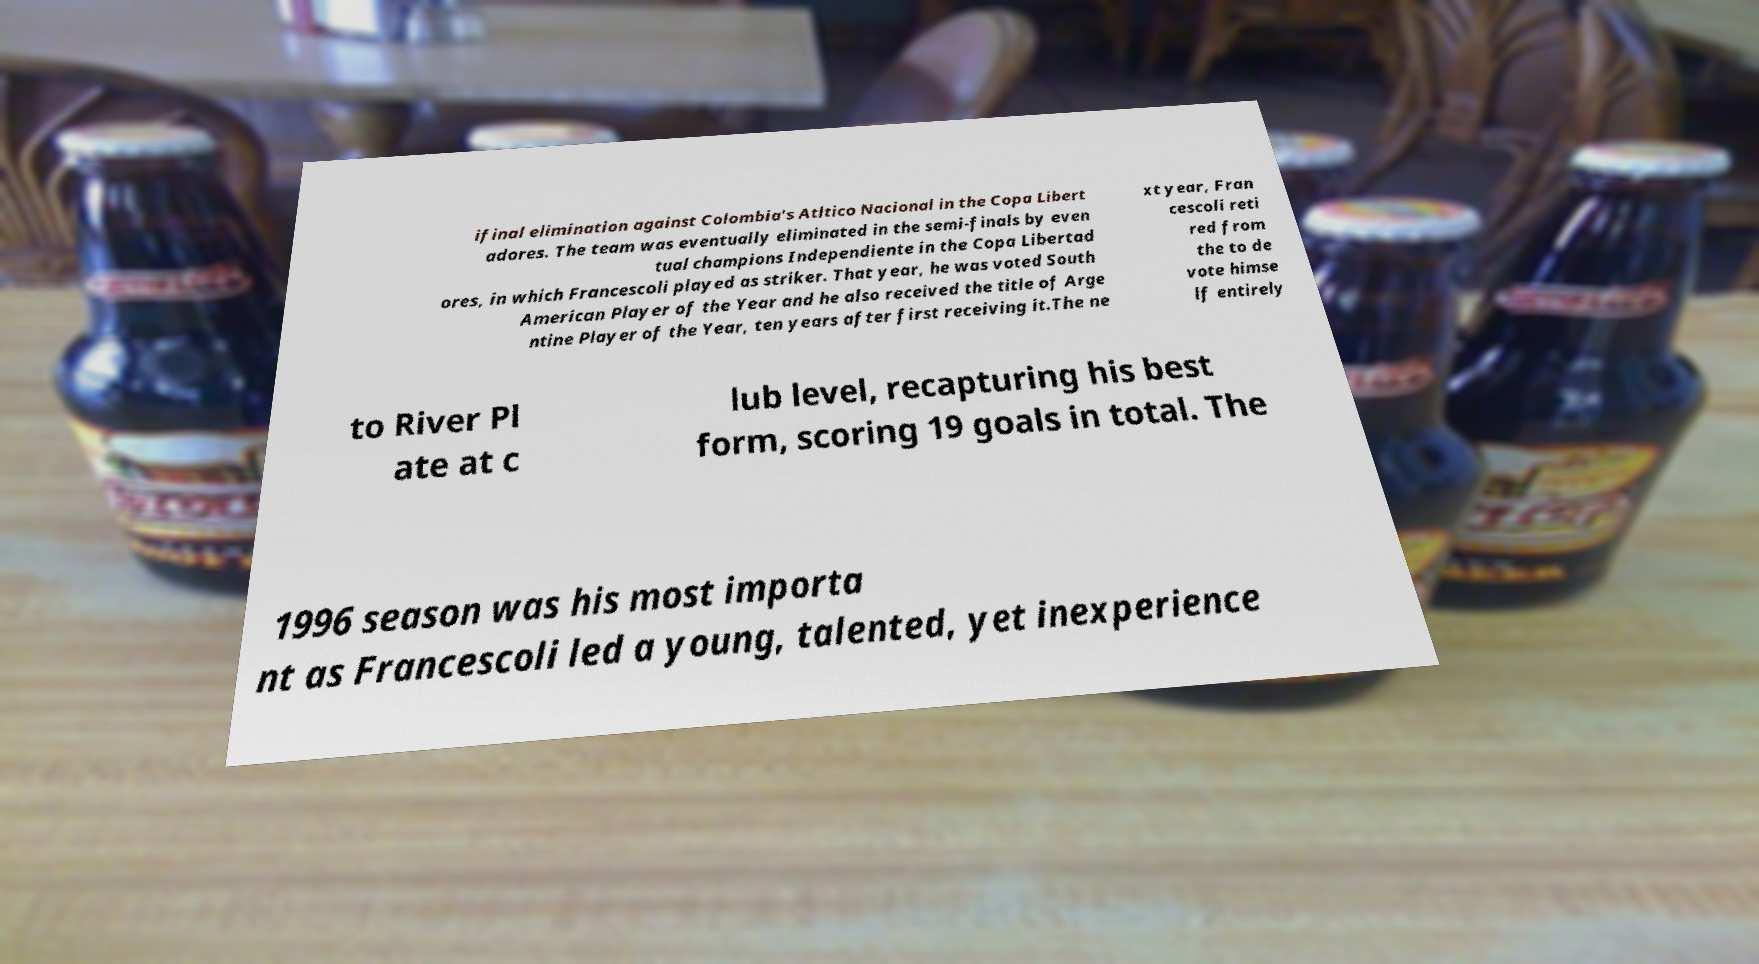Please read and relay the text visible in this image. What does it say? ifinal elimination against Colombia's Atltico Nacional in the Copa Libert adores. The team was eventually eliminated in the semi-finals by even tual champions Independiente in the Copa Libertad ores, in which Francescoli played as striker. That year, he was voted South American Player of the Year and he also received the title of Arge ntine Player of the Year, ten years after first receiving it.The ne xt year, Fran cescoli reti red from the to de vote himse lf entirely to River Pl ate at c lub level, recapturing his best form, scoring 19 goals in total. The 1996 season was his most importa nt as Francescoli led a young, talented, yet inexperience 